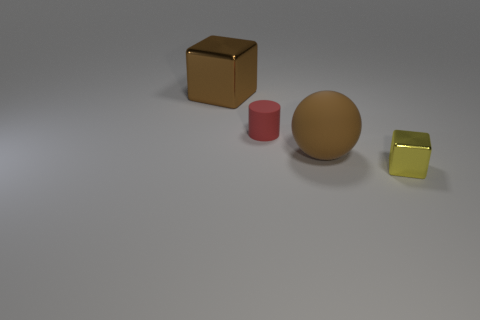The object that is both left of the small block and in front of the red matte thing has what shape?
Give a very brief answer. Sphere. Is the color of the large cube the same as the rubber object right of the red matte thing?
Offer a very short reply. Yes. What color is the cube behind the block that is in front of the tiny object behind the small block?
Offer a very short reply. Brown. The other metallic object that is the same shape as the small yellow metal thing is what color?
Your response must be concise. Brown. Are there an equal number of tiny red cylinders behind the tiny red matte cylinder and brown spheres?
Ensure brevity in your answer.  No. What number of cubes are either purple shiny objects or large brown objects?
Make the answer very short. 1. The thing that is the same material as the big cube is what color?
Your answer should be very brief. Yellow. Do the sphere and the tiny object to the right of the large sphere have the same material?
Your answer should be very brief. No. How many objects are either large gray balls or big shiny cubes?
Keep it short and to the point. 1. What material is the other object that is the same color as the large matte object?
Offer a terse response. Metal. 